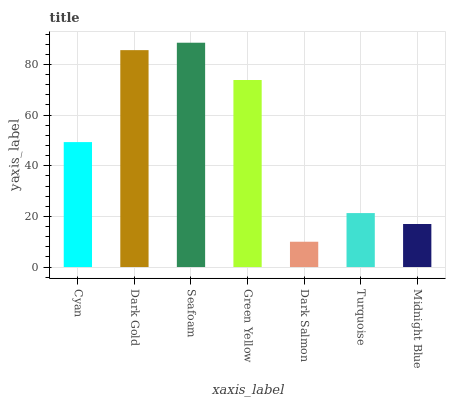Is Dark Salmon the minimum?
Answer yes or no. Yes. Is Seafoam the maximum?
Answer yes or no. Yes. Is Dark Gold the minimum?
Answer yes or no. No. Is Dark Gold the maximum?
Answer yes or no. No. Is Dark Gold greater than Cyan?
Answer yes or no. Yes. Is Cyan less than Dark Gold?
Answer yes or no. Yes. Is Cyan greater than Dark Gold?
Answer yes or no. No. Is Dark Gold less than Cyan?
Answer yes or no. No. Is Cyan the high median?
Answer yes or no. Yes. Is Cyan the low median?
Answer yes or no. Yes. Is Midnight Blue the high median?
Answer yes or no. No. Is Green Yellow the low median?
Answer yes or no. No. 